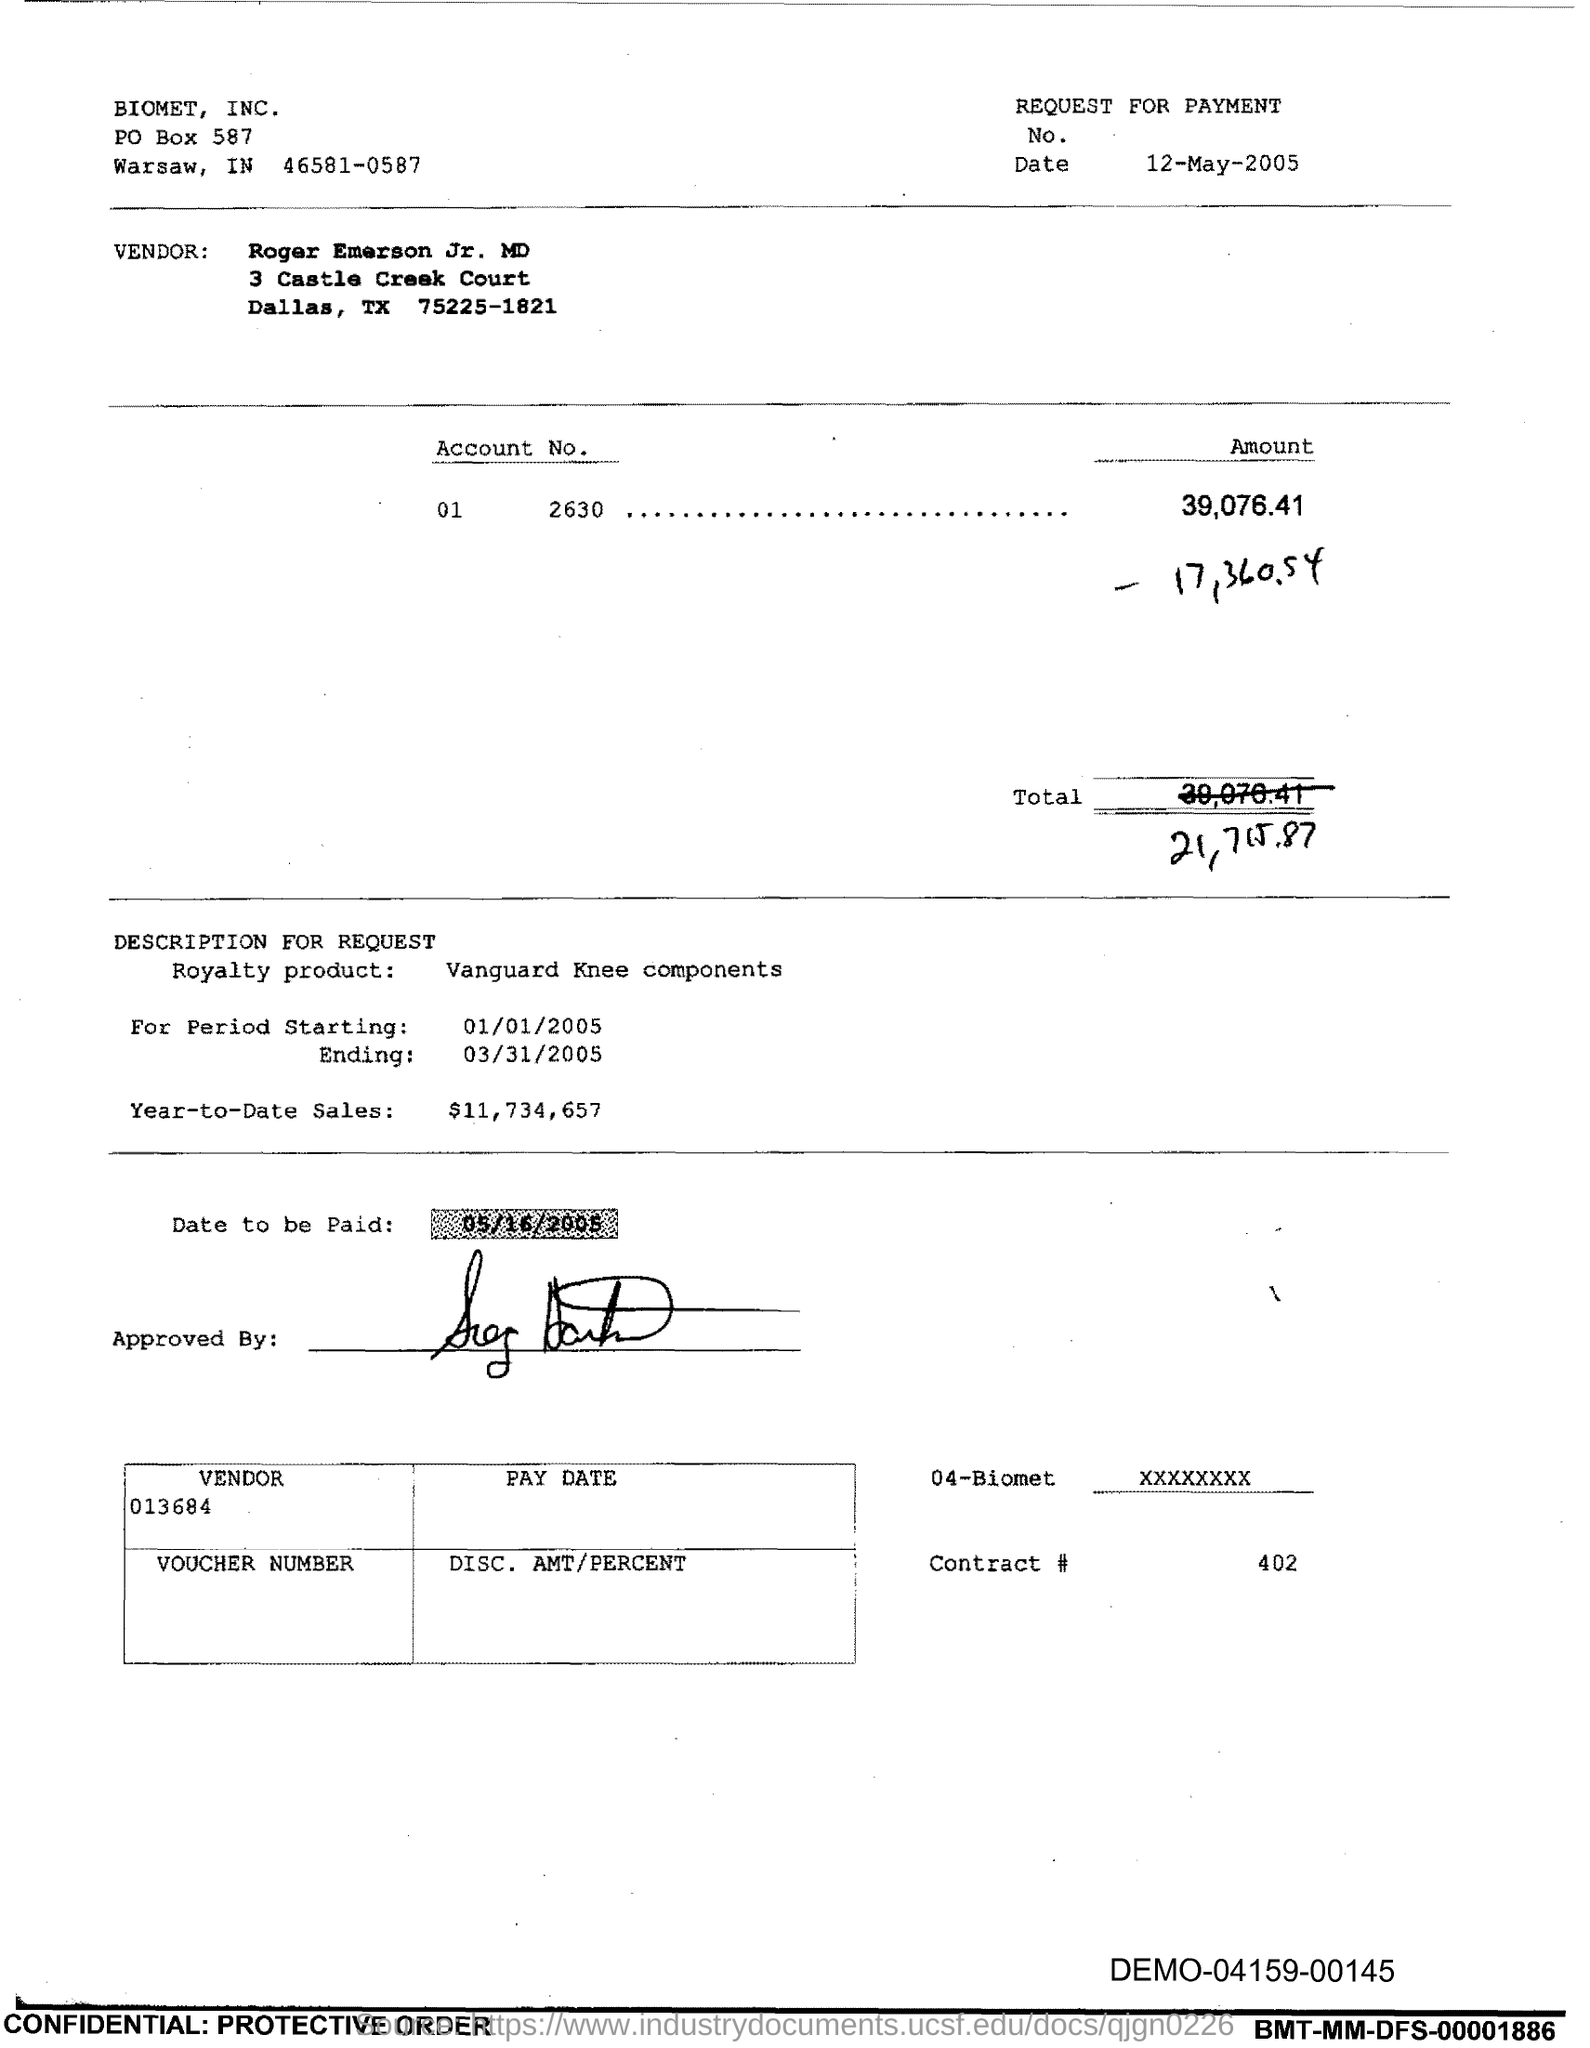Indicate a few pertinent items in this graphic. The royalty product specified in the voucher is Vanguard Knee Components. The issued date of this voucher is 12-May-2005. The year-to-date sales of the royalty product are $11,734,657. The contract number mentioned in the voucher is 402. The account number provided in the voucher is 01 2630. 